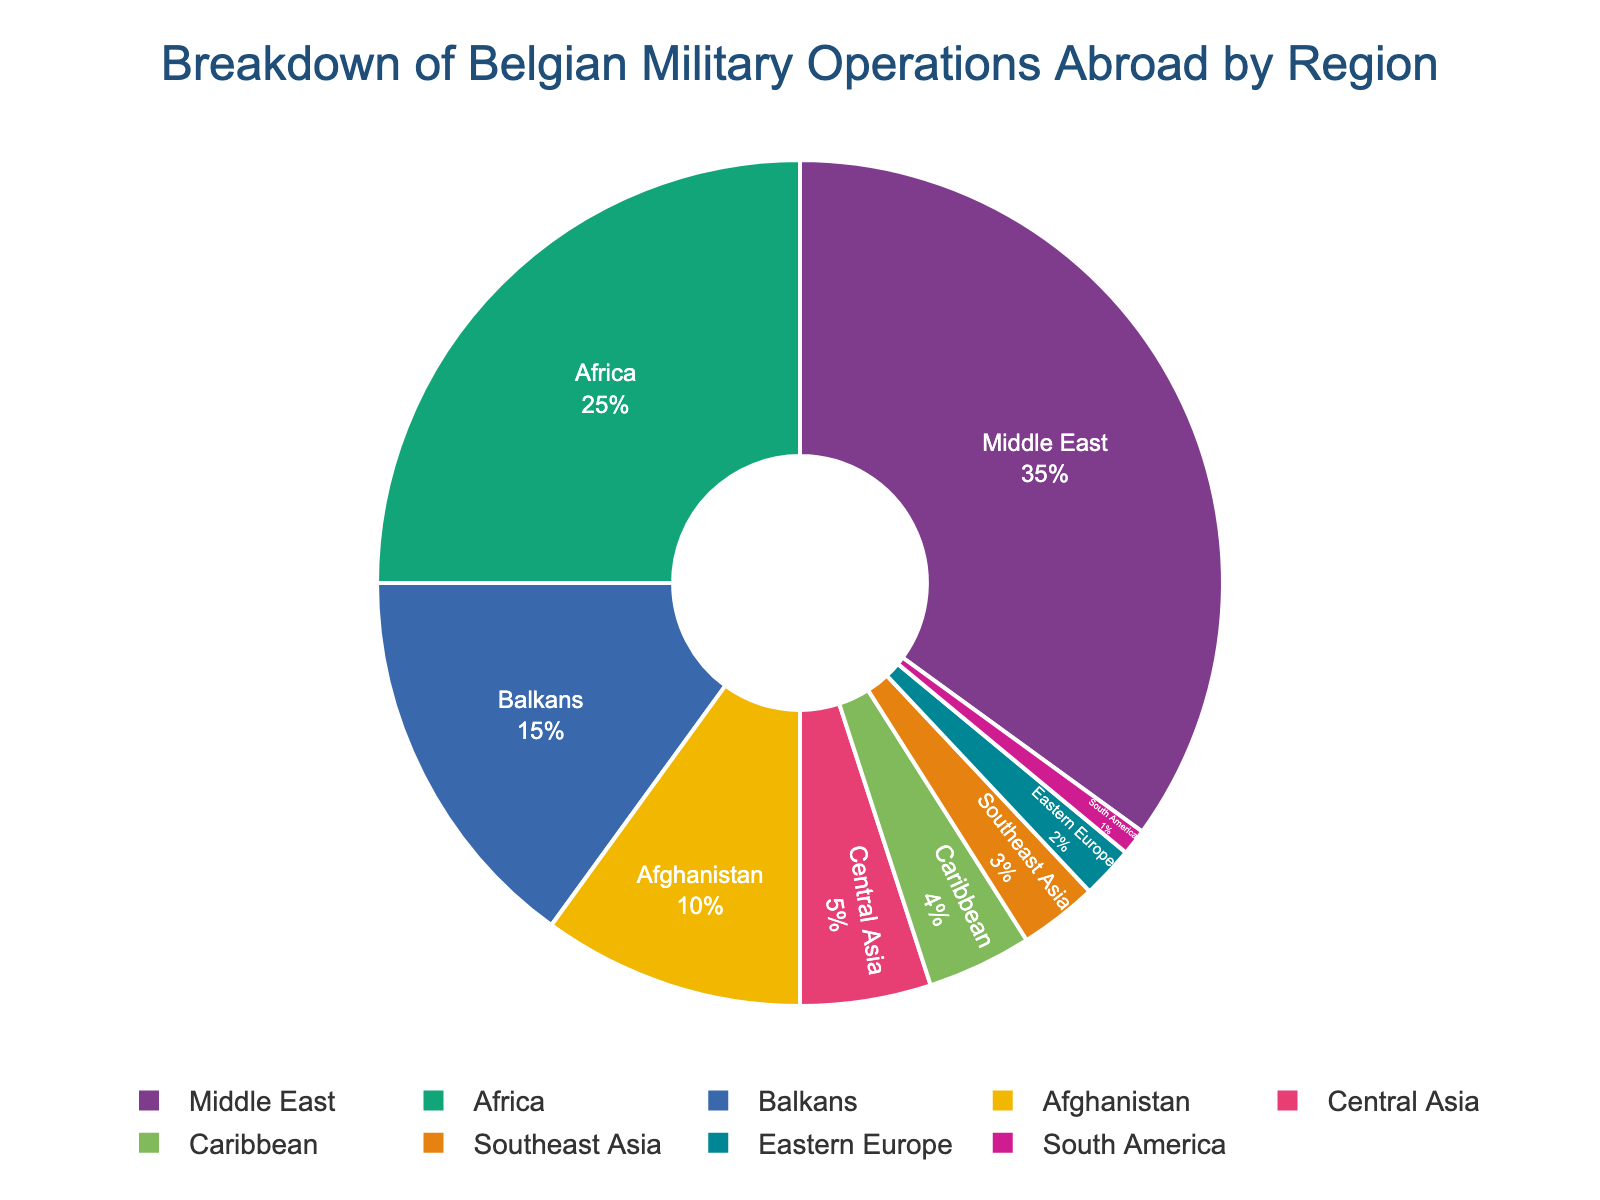Which region has the highest percentage of Belgian military operations abroad? The Middle East region has the largest slice of the pie chart, indicating the highest percentage of operations.
Answer: Middle East Which two regions have the smallest percentages of Belgian military operations abroad combined? Southeast Asia (3%), Eastern Europe (2%), and South America (1%) are the three regions with the smallest percentages. Combined, Southeast Asia and Eastern Europe have a higher percentage (5%) than Southeast Asia and South America (4%) or Eastern Europe and South America (3%).
Answer: Eastern Europe and South America What percentage of Belgian military operations abroad are in Africa and the Balkans combined? From the pie chart, Africa has 25% and the Balkans have 15%. Adding these percentages gives 25% + 15% = 40%.
Answer: 40% Is the percentage of Belgian military operations abroad in Afghanistan greater than in Central Asia? The pie chart shows that Afghanistan has 10% while Central Asia has 5%. Comparatively, 10% is greater than 5%.
Answer: Yes What is the visual attribute used to distinguish different regions in the pie chart? The pie chart uses different colors to represent various regions, helping to quickly distinguish between them.
Answer: Colors What’s the combined percentage of Belgian military operations in the Middle East, Africa, and the Balkans? Middle East: 35%, Africa: 25%, and Balkans: 15%. Combined, their percentage is 35% + 25% + 15% = 75%.
Answer: 75% Which region has double the percentage of Belgian military operations as Central Asia? From the pie chart, Central Asia has 5%. Afghanistan has 10%, which is double the percentage of Central Asia.
Answer: Afghanistan How many regions have a percentage of less than 5%? The regions with percentages less than 5% are Central Asia (5%), Caribbean (4%), Southeast Asia (3%), Eastern Europe (2%), and South America (1%). Only Southeast Asia, Eastern Europe, and South America are less than 5%.
Answer: 3 If you were to combine Caribbean, Southeast Asia, Eastern Europe, and South America, what would their total percentage be? Adding the percentages: Caribbean (4%), Southeast Asia (3%), Eastern Europe (2%), and South America (1%), we get 4% + 3% + 2% + 1% = 10%.
Answer: 10% 